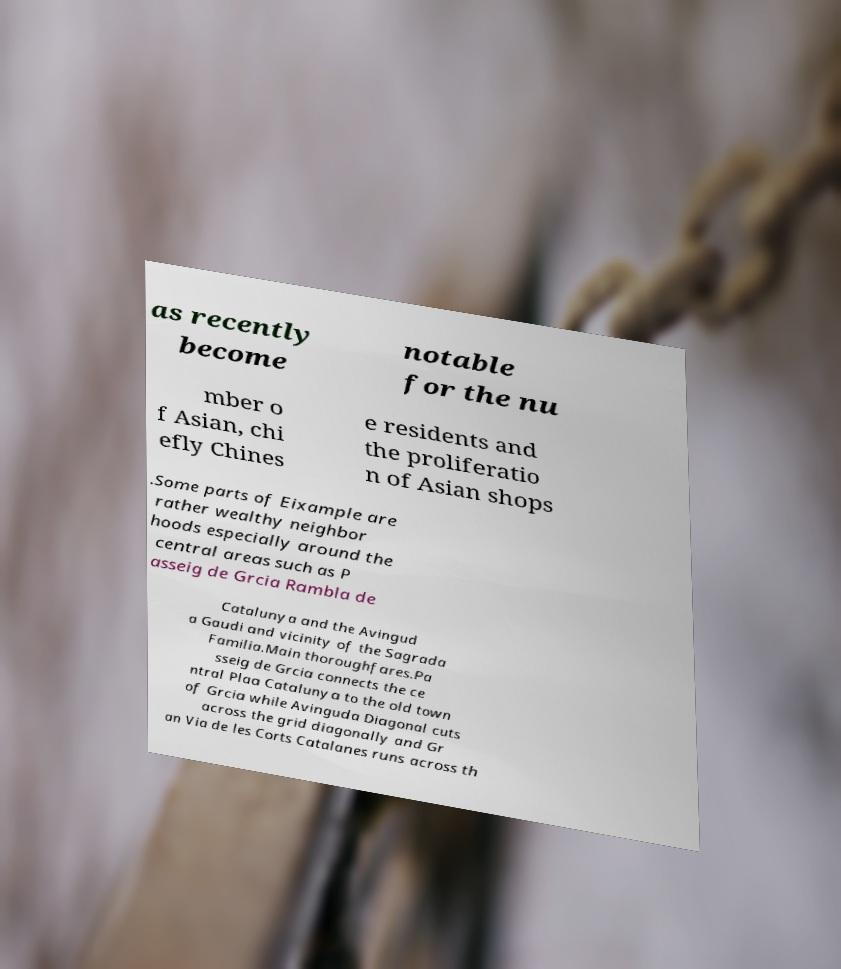Could you extract and type out the text from this image? as recently become notable for the nu mber o f Asian, chi efly Chines e residents and the proliferatio n of Asian shops .Some parts of Eixample are rather wealthy neighbor hoods especially around the central areas such as P asseig de Grcia Rambla de Catalunya and the Avingud a Gaudi and vicinity of the Sagrada Familia.Main thoroughfares.Pa sseig de Grcia connects the ce ntral Plaa Catalunya to the old town of Grcia while Avinguda Diagonal cuts across the grid diagonally and Gr an Via de les Corts Catalanes runs across th 